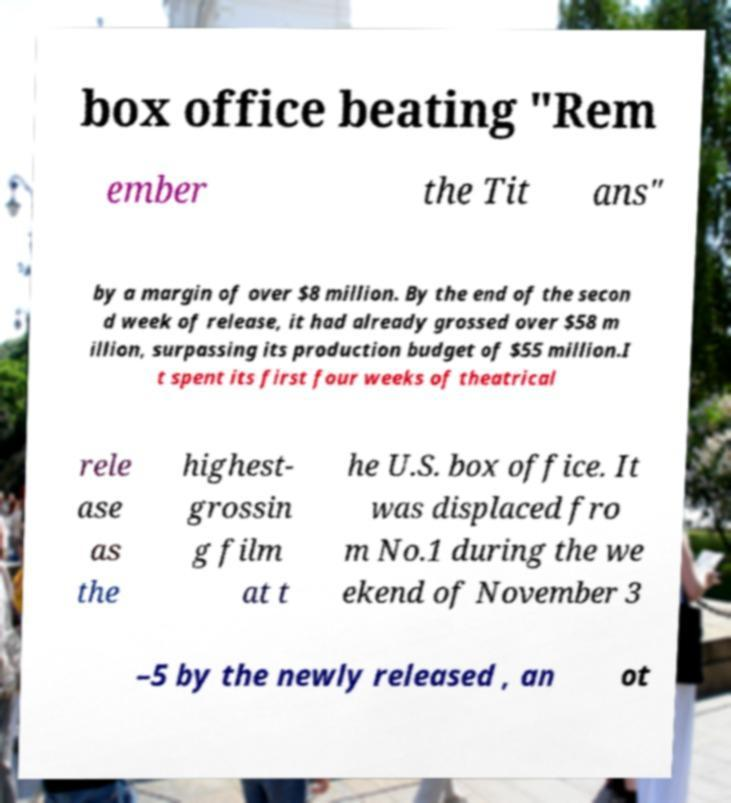I need the written content from this picture converted into text. Can you do that? box office beating "Rem ember the Tit ans" by a margin of over $8 million. By the end of the secon d week of release, it had already grossed over $58 m illion, surpassing its production budget of $55 million.I t spent its first four weeks of theatrical rele ase as the highest- grossin g film at t he U.S. box office. It was displaced fro m No.1 during the we ekend of November 3 –5 by the newly released , an ot 